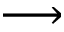Convert formula to latex. <formula><loc_0><loc_0><loc_500><loc_500>\longrightarrow</formula> 